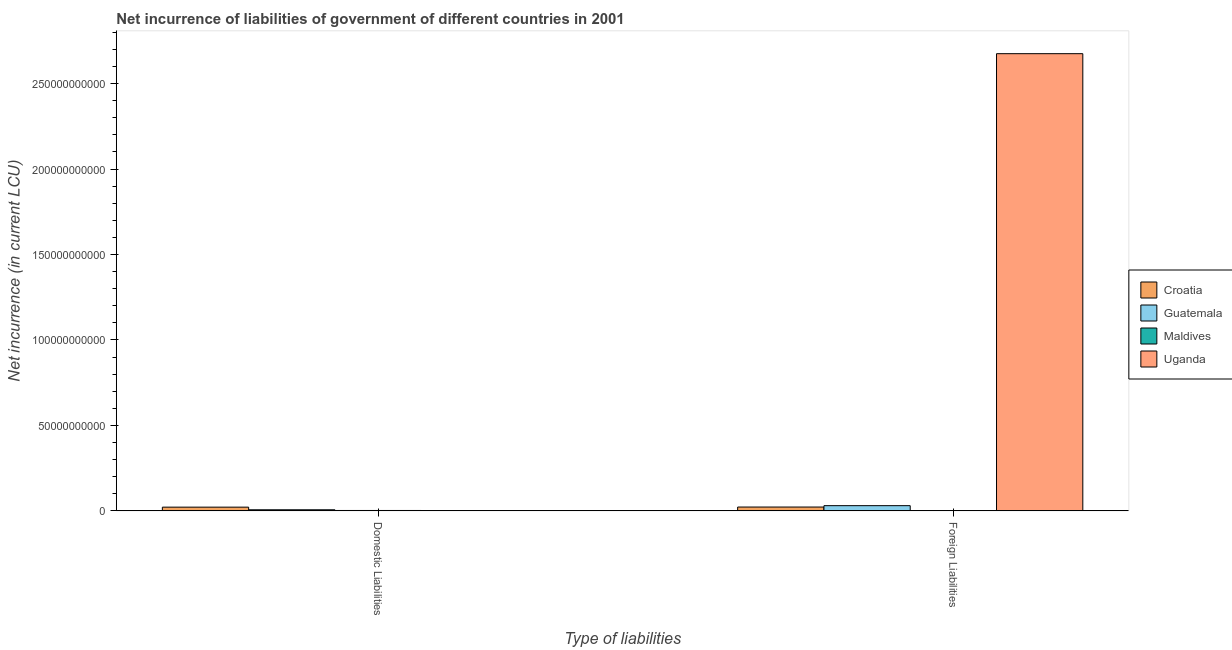How many different coloured bars are there?
Your answer should be very brief. 4. Are the number of bars on each tick of the X-axis equal?
Your answer should be very brief. No. What is the label of the 1st group of bars from the left?
Offer a very short reply. Domestic Liabilities. What is the net incurrence of domestic liabilities in Uganda?
Provide a succinct answer. 0. Across all countries, what is the maximum net incurrence of foreign liabilities?
Provide a succinct answer. 2.67e+11. In which country was the net incurrence of foreign liabilities maximum?
Ensure brevity in your answer.  Uganda. What is the total net incurrence of foreign liabilities in the graph?
Your response must be concise. 2.73e+11. What is the difference between the net incurrence of foreign liabilities in Guatemala and that in Croatia?
Provide a short and direct response. 8.03e+08. What is the difference between the net incurrence of domestic liabilities in Uganda and the net incurrence of foreign liabilities in Croatia?
Make the answer very short. -2.25e+09. What is the average net incurrence of domestic liabilities per country?
Your answer should be very brief. 7.72e+08. What is the difference between the net incurrence of foreign liabilities and net incurrence of domestic liabilities in Maldives?
Your response must be concise. -9.91e+07. What is the ratio of the net incurrence of foreign liabilities in Maldives to that in Uganda?
Your response must be concise. 0. What is the difference between two consecutive major ticks on the Y-axis?
Your answer should be very brief. 5.00e+1. Are the values on the major ticks of Y-axis written in scientific E-notation?
Give a very brief answer. No. Does the graph contain grids?
Give a very brief answer. No. What is the title of the graph?
Your answer should be very brief. Net incurrence of liabilities of government of different countries in 2001. What is the label or title of the X-axis?
Your answer should be very brief. Type of liabilities. What is the label or title of the Y-axis?
Make the answer very short. Net incurrence (in current LCU). What is the Net incurrence (in current LCU) of Croatia in Domestic Liabilities?
Give a very brief answer. 2.19e+09. What is the Net incurrence (in current LCU) in Guatemala in Domestic Liabilities?
Provide a succinct answer. 6.51e+08. What is the Net incurrence (in current LCU) in Maldives in Domestic Liabilities?
Your response must be concise. 2.45e+08. What is the Net incurrence (in current LCU) of Croatia in Foreign Liabilities?
Your answer should be very brief. 2.25e+09. What is the Net incurrence (in current LCU) of Guatemala in Foreign Liabilities?
Offer a very short reply. 3.05e+09. What is the Net incurrence (in current LCU) of Maldives in Foreign Liabilities?
Ensure brevity in your answer.  1.46e+08. What is the Net incurrence (in current LCU) in Uganda in Foreign Liabilities?
Offer a very short reply. 2.67e+11. Across all Type of liabilities, what is the maximum Net incurrence (in current LCU) in Croatia?
Your response must be concise. 2.25e+09. Across all Type of liabilities, what is the maximum Net incurrence (in current LCU) in Guatemala?
Offer a terse response. 3.05e+09. Across all Type of liabilities, what is the maximum Net incurrence (in current LCU) in Maldives?
Your answer should be compact. 2.45e+08. Across all Type of liabilities, what is the maximum Net incurrence (in current LCU) of Uganda?
Your answer should be compact. 2.67e+11. Across all Type of liabilities, what is the minimum Net incurrence (in current LCU) of Croatia?
Make the answer very short. 2.19e+09. Across all Type of liabilities, what is the minimum Net incurrence (in current LCU) of Guatemala?
Provide a short and direct response. 6.51e+08. Across all Type of liabilities, what is the minimum Net incurrence (in current LCU) in Maldives?
Provide a succinct answer. 1.46e+08. What is the total Net incurrence (in current LCU) of Croatia in the graph?
Offer a very short reply. 4.44e+09. What is the total Net incurrence (in current LCU) in Guatemala in the graph?
Ensure brevity in your answer.  3.71e+09. What is the total Net incurrence (in current LCU) of Maldives in the graph?
Offer a terse response. 3.91e+08. What is the total Net incurrence (in current LCU) of Uganda in the graph?
Your response must be concise. 2.67e+11. What is the difference between the Net incurrence (in current LCU) of Croatia in Domestic Liabilities and that in Foreign Liabilities?
Offer a very short reply. -5.90e+07. What is the difference between the Net incurrence (in current LCU) in Guatemala in Domestic Liabilities and that in Foreign Liabilities?
Offer a very short reply. -2.40e+09. What is the difference between the Net incurrence (in current LCU) in Maldives in Domestic Liabilities and that in Foreign Liabilities?
Offer a terse response. 9.91e+07. What is the difference between the Net incurrence (in current LCU) in Croatia in Domestic Liabilities and the Net incurrence (in current LCU) in Guatemala in Foreign Liabilities?
Provide a short and direct response. -8.62e+08. What is the difference between the Net incurrence (in current LCU) in Croatia in Domestic Liabilities and the Net incurrence (in current LCU) in Maldives in Foreign Liabilities?
Your answer should be very brief. 2.05e+09. What is the difference between the Net incurrence (in current LCU) in Croatia in Domestic Liabilities and the Net incurrence (in current LCU) in Uganda in Foreign Liabilities?
Give a very brief answer. -2.65e+11. What is the difference between the Net incurrence (in current LCU) in Guatemala in Domestic Liabilities and the Net incurrence (in current LCU) in Maldives in Foreign Liabilities?
Ensure brevity in your answer.  5.05e+08. What is the difference between the Net incurrence (in current LCU) in Guatemala in Domestic Liabilities and the Net incurrence (in current LCU) in Uganda in Foreign Liabilities?
Offer a very short reply. -2.67e+11. What is the difference between the Net incurrence (in current LCU) in Maldives in Domestic Liabilities and the Net incurrence (in current LCU) in Uganda in Foreign Liabilities?
Your response must be concise. -2.67e+11. What is the average Net incurrence (in current LCU) in Croatia per Type of liabilities?
Your response must be concise. 2.22e+09. What is the average Net incurrence (in current LCU) in Guatemala per Type of liabilities?
Provide a succinct answer. 1.85e+09. What is the average Net incurrence (in current LCU) of Maldives per Type of liabilities?
Make the answer very short. 1.95e+08. What is the average Net incurrence (in current LCU) of Uganda per Type of liabilities?
Your answer should be compact. 1.34e+11. What is the difference between the Net incurrence (in current LCU) of Croatia and Net incurrence (in current LCU) of Guatemala in Domestic Liabilities?
Your answer should be compact. 1.54e+09. What is the difference between the Net incurrence (in current LCU) in Croatia and Net incurrence (in current LCU) in Maldives in Domestic Liabilities?
Provide a short and direct response. 1.95e+09. What is the difference between the Net incurrence (in current LCU) of Guatemala and Net incurrence (in current LCU) of Maldives in Domestic Liabilities?
Make the answer very short. 4.06e+08. What is the difference between the Net incurrence (in current LCU) of Croatia and Net incurrence (in current LCU) of Guatemala in Foreign Liabilities?
Provide a succinct answer. -8.03e+08. What is the difference between the Net incurrence (in current LCU) of Croatia and Net incurrence (in current LCU) of Maldives in Foreign Liabilities?
Provide a short and direct response. 2.11e+09. What is the difference between the Net incurrence (in current LCU) in Croatia and Net incurrence (in current LCU) in Uganda in Foreign Liabilities?
Provide a succinct answer. -2.65e+11. What is the difference between the Net incurrence (in current LCU) in Guatemala and Net incurrence (in current LCU) in Maldives in Foreign Liabilities?
Make the answer very short. 2.91e+09. What is the difference between the Net incurrence (in current LCU) of Guatemala and Net incurrence (in current LCU) of Uganda in Foreign Liabilities?
Your answer should be very brief. -2.64e+11. What is the difference between the Net incurrence (in current LCU) of Maldives and Net incurrence (in current LCU) of Uganda in Foreign Liabilities?
Give a very brief answer. -2.67e+11. What is the ratio of the Net incurrence (in current LCU) in Croatia in Domestic Liabilities to that in Foreign Liabilities?
Provide a short and direct response. 0.97. What is the ratio of the Net incurrence (in current LCU) in Guatemala in Domestic Liabilities to that in Foreign Liabilities?
Provide a short and direct response. 0.21. What is the ratio of the Net incurrence (in current LCU) of Maldives in Domestic Liabilities to that in Foreign Liabilities?
Ensure brevity in your answer.  1.68. What is the difference between the highest and the second highest Net incurrence (in current LCU) in Croatia?
Make the answer very short. 5.90e+07. What is the difference between the highest and the second highest Net incurrence (in current LCU) in Guatemala?
Offer a terse response. 2.40e+09. What is the difference between the highest and the second highest Net incurrence (in current LCU) in Maldives?
Make the answer very short. 9.91e+07. What is the difference between the highest and the lowest Net incurrence (in current LCU) in Croatia?
Your response must be concise. 5.90e+07. What is the difference between the highest and the lowest Net incurrence (in current LCU) of Guatemala?
Keep it short and to the point. 2.40e+09. What is the difference between the highest and the lowest Net incurrence (in current LCU) in Maldives?
Give a very brief answer. 9.91e+07. What is the difference between the highest and the lowest Net incurrence (in current LCU) of Uganda?
Give a very brief answer. 2.67e+11. 